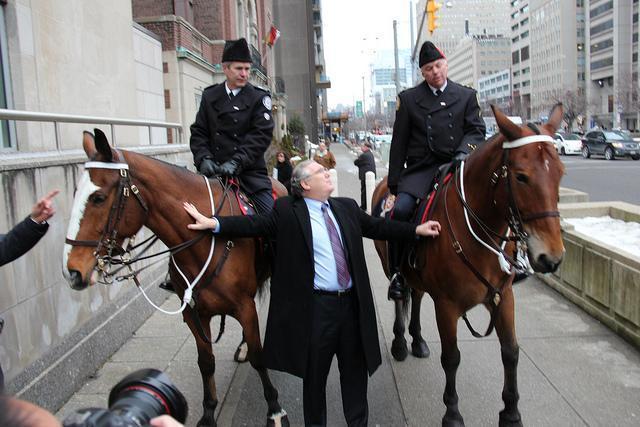How many officers are riding horses?
Give a very brief answer. 2. How many men are there?
Give a very brief answer. 3. How many people are in the photo?
Give a very brief answer. 4. How many horses are there?
Give a very brief answer. 2. 